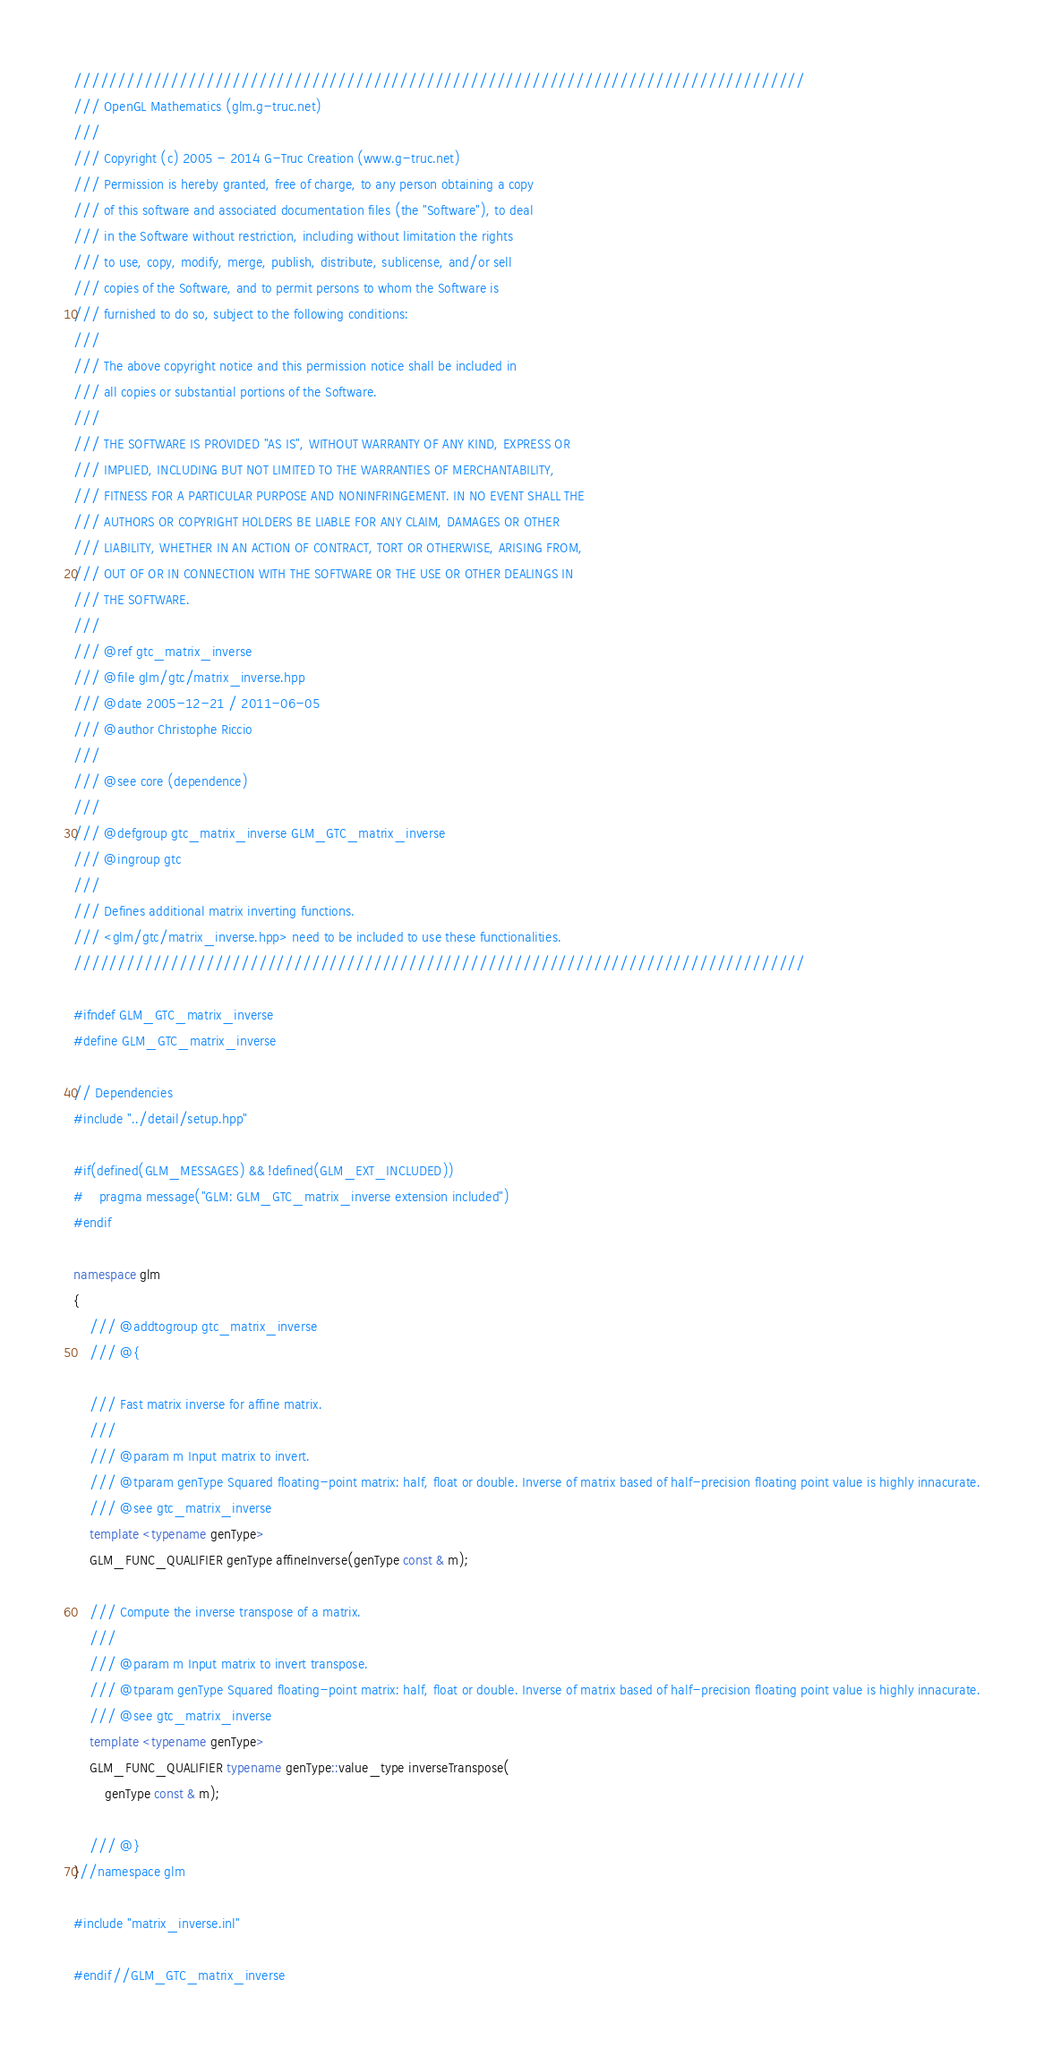<code> <loc_0><loc_0><loc_500><loc_500><_C++_>///////////////////////////////////////////////////////////////////////////////////
/// OpenGL Mathematics (glm.g-truc.net)
///
/// Copyright (c) 2005 - 2014 G-Truc Creation (www.g-truc.net)
/// Permission is hereby granted, free of charge, to any person obtaining a copy
/// of this software and associated documentation files (the "Software"), to deal
/// in the Software without restriction, including without limitation the rights
/// to use, copy, modify, merge, publish, distribute, sublicense, and/or sell
/// copies of the Software, and to permit persons to whom the Software is
/// furnished to do so, subject to the following conditions:
/// 
/// The above copyright notice and this permission notice shall be included in
/// all copies or substantial portions of the Software.
/// 
/// THE SOFTWARE IS PROVIDED "AS IS", WITHOUT WARRANTY OF ANY KIND, EXPRESS OR
/// IMPLIED, INCLUDING BUT NOT LIMITED TO THE WARRANTIES OF MERCHANTABILITY,
/// FITNESS FOR A PARTICULAR PURPOSE AND NONINFRINGEMENT. IN NO EVENT SHALL THE
/// AUTHORS OR COPYRIGHT HOLDERS BE LIABLE FOR ANY CLAIM, DAMAGES OR OTHER
/// LIABILITY, WHETHER IN AN ACTION OF CONTRACT, TORT OR OTHERWISE, ARISING FROM,
/// OUT OF OR IN CONNECTION WITH THE SOFTWARE OR THE USE OR OTHER DEALINGS IN
/// THE SOFTWARE.
///
/// @ref gtc_matrix_inverse
/// @file glm/gtc/matrix_inverse.hpp
/// @date 2005-12-21 / 2011-06-05
/// @author Christophe Riccio
///
/// @see core (dependence)
/// 
/// @defgroup gtc_matrix_inverse GLM_GTC_matrix_inverse
/// @ingroup gtc
/// 
/// Defines additional matrix inverting functions.
/// <glm/gtc/matrix_inverse.hpp> need to be included to use these functionalities.
///////////////////////////////////////////////////////////////////////////////////

#ifndef GLM_GTC_matrix_inverse
#define GLM_GTC_matrix_inverse

// Dependencies
#include "../detail/setup.hpp"

#if(defined(GLM_MESSAGES) && !defined(GLM_EXT_INCLUDED))
#	pragma message("GLM: GLM_GTC_matrix_inverse extension included")
#endif

namespace glm
{
	/// @addtogroup gtc_matrix_inverse
	/// @{

	/// Fast matrix inverse for affine matrix.
	/// 
	/// @param m Input matrix to invert.
	/// @tparam genType Squared floating-point matrix: half, float or double. Inverse of matrix based of half-precision floating point value is highly innacurate.
	/// @see gtc_matrix_inverse
	template <typename genType> 
	GLM_FUNC_QUALIFIER genType affineInverse(genType const & m);

	/// Compute the inverse transpose of a matrix.
	/// 
	/// @param m Input matrix to invert transpose.
	/// @tparam genType Squared floating-point matrix: half, float or double. Inverse of matrix based of half-precision floating point value is highly innacurate.
	/// @see gtc_matrix_inverse
	template <typename genType> 
	GLM_FUNC_QUALIFIER typename genType::value_type inverseTranspose(
		genType const & m);

	/// @}
}//namespace glm

#include "matrix_inverse.inl"

#endif//GLM_GTC_matrix_inverse
</code> 